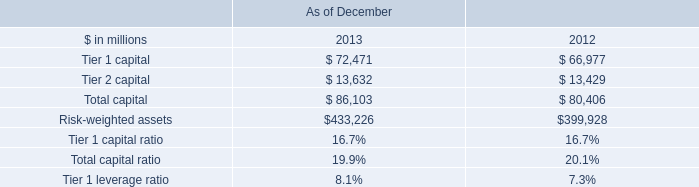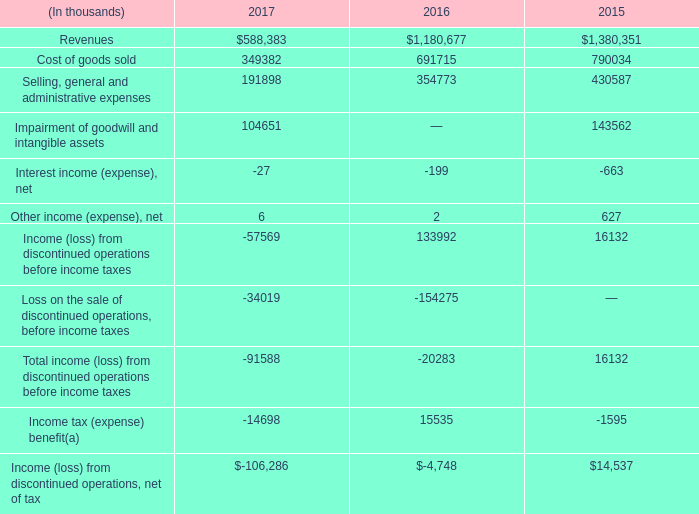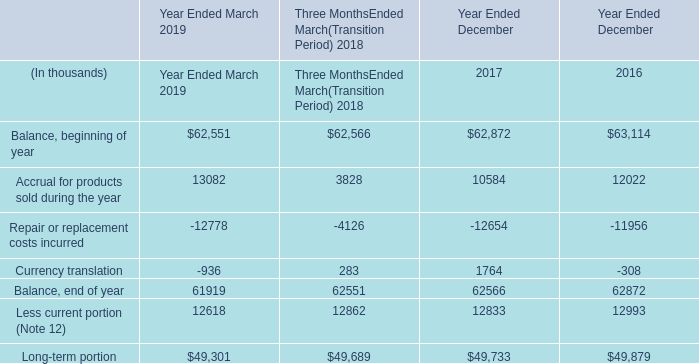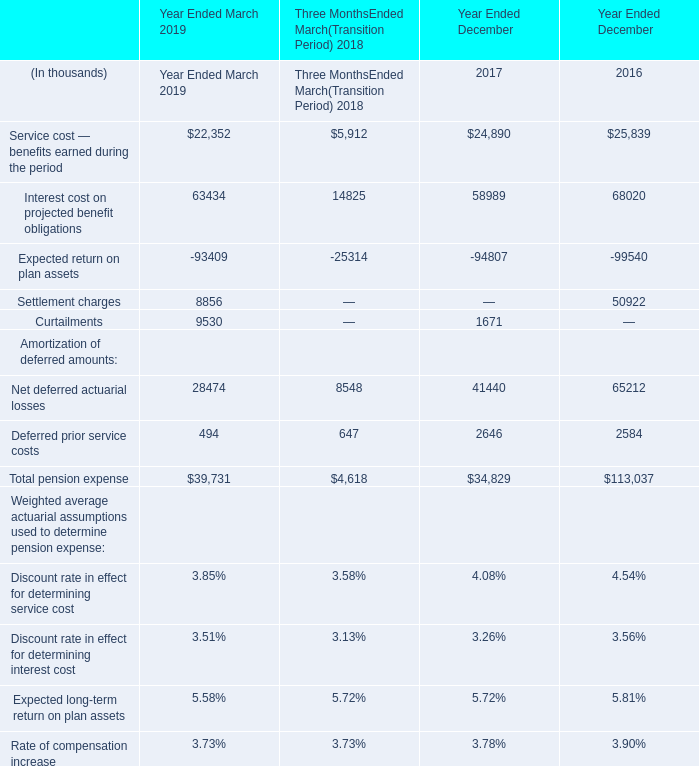What's the increasing rate of Less current portion (Note 12) in 2019? (in %) 
Computations: ((12618 - 12862) / 12862)
Answer: -0.01897. 